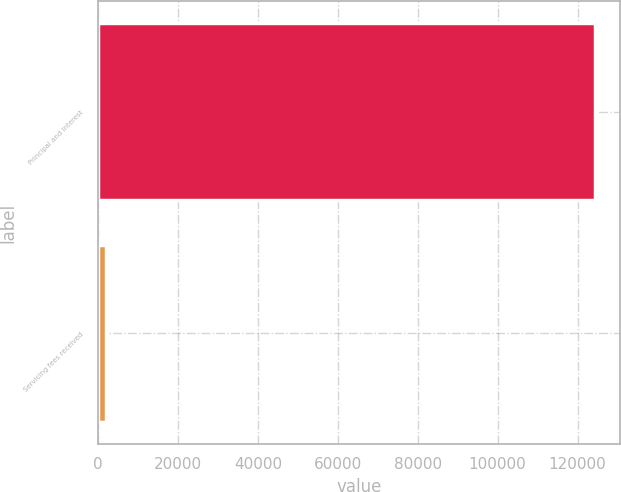Convert chart to OTSL. <chart><loc_0><loc_0><loc_500><loc_500><bar_chart><fcel>Principal and interest<fcel>Servicing fees received<nl><fcel>124469<fcel>1864<nl></chart> 